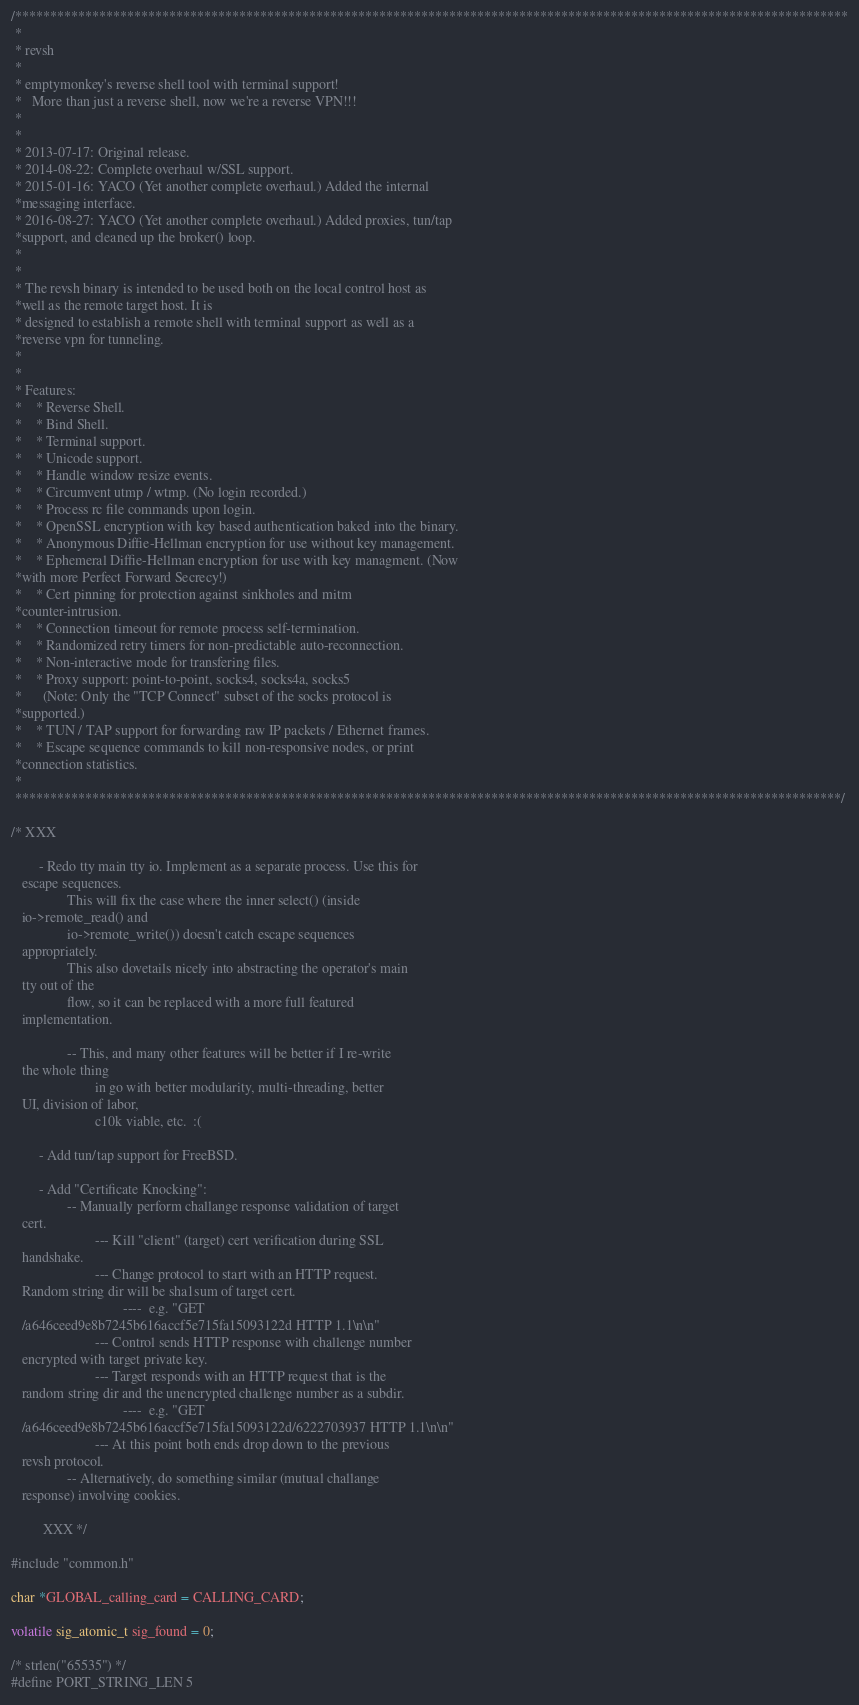Convert code to text. <code><loc_0><loc_0><loc_500><loc_500><_C_>
/***********************************************************************************************************************
 *
 * revsh
 *
 * emptymonkey's reverse shell tool with terminal support!
 *   More than just a reverse shell, now we're a reverse VPN!!!
 *
 *
 * 2013-07-17: Original release.
 * 2014-08-22: Complete overhaul w/SSL support.
 * 2015-01-16: YACO (Yet another complete overhaul.) Added the internal
 *messaging interface.
 * 2016-08-27: YACO (Yet another complete overhaul.) Added proxies, tun/tap
 *support, and cleaned up the broker() loop.
 *
 *
 * The revsh binary is intended to be used both on the local control host as
 *well as the remote target host. It is
 * designed to establish a remote shell with terminal support as well as a
 *reverse vpn for tunneling.
 *
 *
 * Features:
 *    * Reverse Shell.
 *    * Bind Shell.
 *    * Terminal support.
 *    * Unicode support.
 *    * Handle window resize events.
 *    * Circumvent utmp / wtmp. (No login recorded.)
 *    * Process rc file commands upon login.
 *    * OpenSSL encryption with key based authentication baked into the binary.
 *    * Anonymous Diffie-Hellman encryption for use without key management.
 *    * Ephemeral Diffie-Hellman encryption for use with key managment. (Now
 *with more Perfect Forward Secrecy!)
 *    * Cert pinning for protection against sinkholes and mitm
 *counter-intrusion.
 *    * Connection timeout for remote process self-termination.
 *    * Randomized retry timers for non-predictable auto-reconnection.
 *    * Non-interactive mode for transfering files.
 *    * Proxy support: point-to-point, socks4, socks4a, socks5
 *      (Note: Only the "TCP Connect" subset of the socks protocol is
 *supported.)
 *    * TUN / TAP support for forwarding raw IP packets / Ethernet frames.
 *    * Escape sequence commands to kill non-responsive nodes, or print
 *connection statistics.
 *
 **********************************************************************************************************************/

/* XXX

        - Redo tty main tty io. Implement as a separate process. Use this for
   escape sequences.
                This will fix the case where the inner select() (inside
   io->remote_read() and
                io->remote_write()) doesn't catch escape sequences
   appropriately.
                This also dovetails nicely into abstracting the operator's main
   tty out of the
                flow, so it can be replaced with a more full featured
   implementation.

                -- This, and many other features will be better if I re-write
   the whole thing
                        in go with better modularity, multi-threading, better
   UI, division of labor,
                        c10k viable, etc.  :(

        - Add tun/tap support for FreeBSD.

        - Add "Certificate Knocking":
                -- Manually perform challange response validation of target
   cert.
                        --- Kill "client" (target) cert verification during SSL
   handshake.
                        --- Change protocol to start with an HTTP request.
   Random string dir will be sha1sum of target cert.
                                ----  e.g. "GET
   /a646ceed9e8b7245b616accf5e715fa15093122d HTTP 1.1\n\n"
                        --- Control sends HTTP response with challenge number
   encrypted with target private key.
                        --- Target responds with an HTTP request that is the
   random string dir and the unencrypted challenge number as a subdir.
                                ----  e.g. "GET
   /a646ceed9e8b7245b616accf5e715fa15093122d/6222703937 HTTP 1.1\n\n"
                        --- At this point both ends drop down to the previous
   revsh protocol.
                -- Alternatively, do something similar (mutual challange
   response) involving cookies.

         XXX */

#include "common.h"

char *GLOBAL_calling_card = CALLING_CARD;

volatile sig_atomic_t sig_found = 0;

/* strlen("65535") */
#define PORT_STRING_LEN 5
</code> 